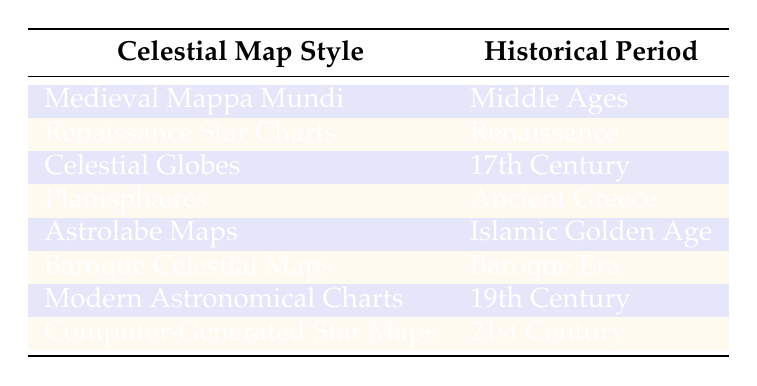What celestial map style corresponds to the Islamic Golden Age? The table lists "Astrolabe Maps" under the historical period of the Islamic Golden Age. Therefore, the celestial map style that corresponds to this period is "Astrolabe Maps."
Answer: Astrolabe Maps How many celestial map styles are categorized under the Renaissance period? Referring to the table, there is one style listed under the Renaissance period: "Renaissance Star Charts." Thus, the count is one.
Answer: 1 Is Baroque Celestial Maps associated with the 17th Century? Looking at the table, "Baroque Celestial Maps" is listed under the Baroque Era, while "Celestial Globes" corresponds to the 17th Century. Therefore, the statement is false.
Answer: No What is the earliest celestial map style mentioned in the table? The earliest style listed is "Planisphæres," which is categorized under Ancient Greece, making it the oldest style in the provided data.
Answer: Planisphæres How many centuries are represented in the celestial map styles after the Middle Ages? The periods after the Middle Ages listed in the table are Renaissance, 17th Century, Baroque Era, 19th Century, and 21st Century, comprising five distinct centuries.
Answer: 5 Are Modern Astronomical Charts the latest style listed in the table? By examining the table, "Computer-Generated Star Maps" is the most recent style listed under the 21st Century, so the statement about Modern Astronomical Charts being the latest is false.
Answer: No Which celestial map styles belong to the 17th Century and Baroque Era? According to the table, "Celestial Globes" belongs to the 17th Century, and "Baroque Celestial Maps" corresponds to the Baroque Era. Therefore, these two styles represent these periods respectively.
Answer: Celestial Globes; Baroque Celestial Maps What celestial map style would have been used during the Baroque Era? The table indicates that "Baroque Celestial Maps" is the style associated with the Baroque Era. Thus, this style would have been used during that period.
Answer: Baroque Celestial Maps 